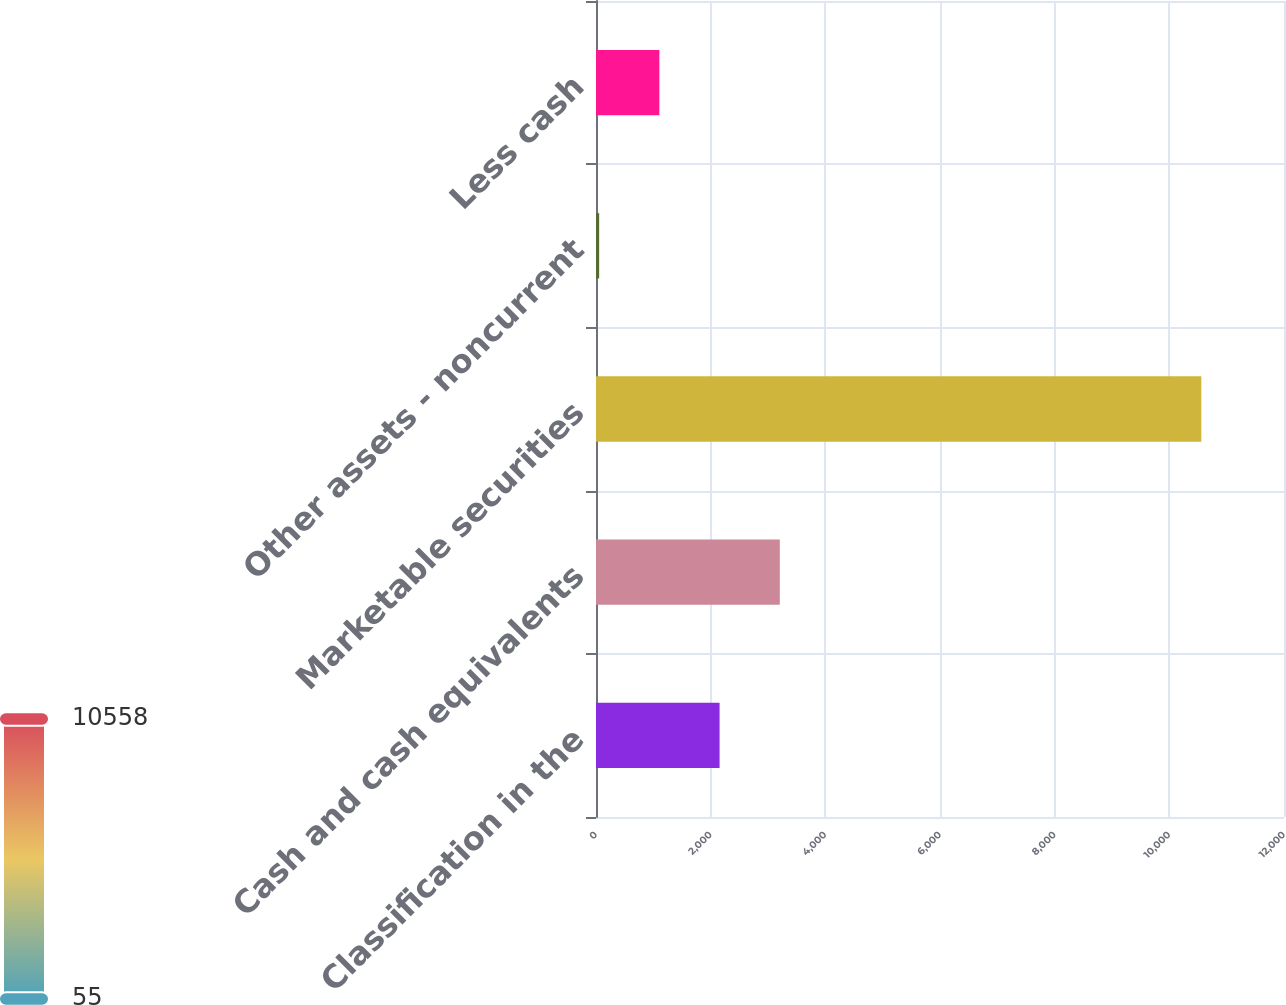Convert chart. <chart><loc_0><loc_0><loc_500><loc_500><bar_chart><fcel>Classification in the<fcel>Cash and cash equivalents<fcel>Marketable securities<fcel>Other assets - noncurrent<fcel>Less cash<nl><fcel>2155.6<fcel>3205.9<fcel>10558<fcel>55<fcel>1105.3<nl></chart> 